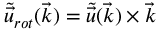Convert formula to latex. <formula><loc_0><loc_0><loc_500><loc_500>\tilde { \ V e c { u } } _ { r o t } ( \ V e c { k } ) = \tilde { \ V e c { u } } ( \ V e c { k } ) \times \ V e c { k }</formula> 